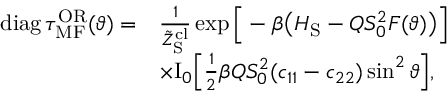Convert formula to latex. <formula><loc_0><loc_0><loc_500><loc_500>\begin{array} { r l } { d i a g \, \tau _ { M F } ^ { O R } ( \vartheta ) = } & { \frac { 1 } { \tilde { Z } _ { S } ^ { c l } } \exp \left [ - \beta \left ( H _ { S } - Q S _ { 0 } ^ { 2 } F ( \vartheta ) \right ) \right ] } \\ & { \times I _ { 0 } \left [ \frac { 1 } { 2 } \beta Q S _ { 0 } ^ { 2 } ( c _ { 1 1 } - c _ { 2 2 } ) \sin ^ { 2 } \vartheta \right ] , } \end{array}</formula> 